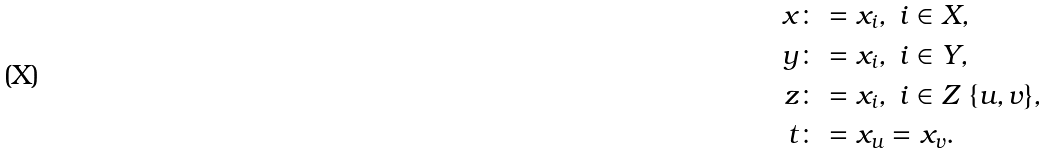<formula> <loc_0><loc_0><loc_500><loc_500>x & \colon = x _ { i } , \ i \in X , \\ y & \colon = x _ { i } , \ i \in Y , \\ z & \colon = x _ { i } , \ i \in Z \ \{ u , v \} , \\ t & \colon = x _ { u } = x _ { v } .</formula> 